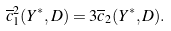<formula> <loc_0><loc_0><loc_500><loc_500>\overline { c } _ { 1 } ^ { 2 } ( Y ^ { * } , D ) = 3 \overline { c } _ { 2 } ( Y ^ { * } , D ) .</formula> 